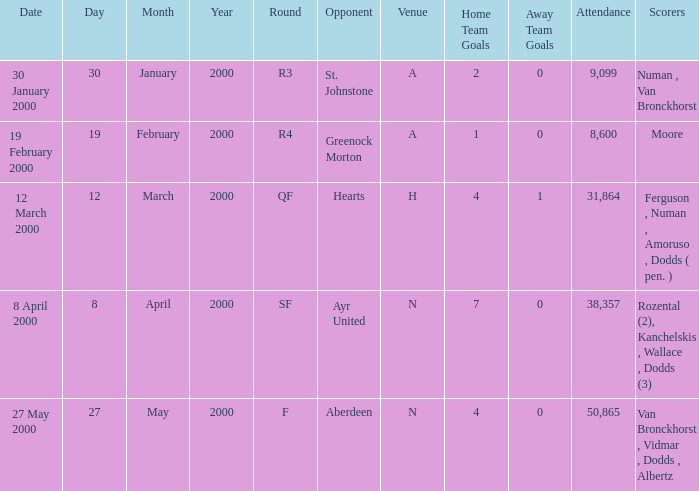Who was in a with opponent St. Johnstone? Numan , Van Bronckhorst. 